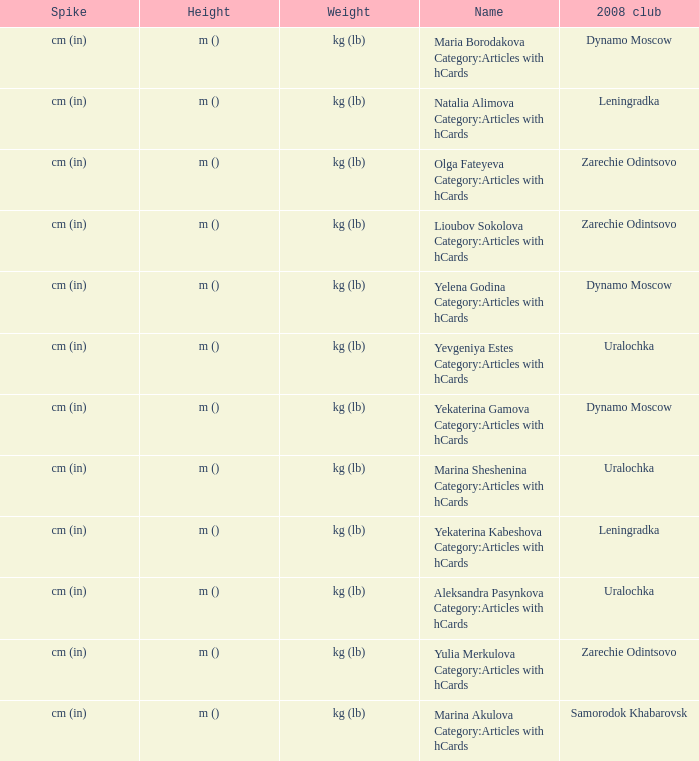What is the name when the 2008 club is uralochka? Yevgeniya Estes Category:Articles with hCards, Marina Sheshenina Category:Articles with hCards, Aleksandra Pasynkova Category:Articles with hCards. 